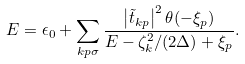<formula> <loc_0><loc_0><loc_500><loc_500>E = \epsilon _ { 0 } + \sum _ { k p \sigma } \frac { \left | \tilde { t } _ { k p } \right | ^ { 2 } \theta ( - \xi _ { p } ) } { E - \zeta ^ { 2 } _ { k } / ( 2 \Delta ) + \xi _ { p } } .</formula> 